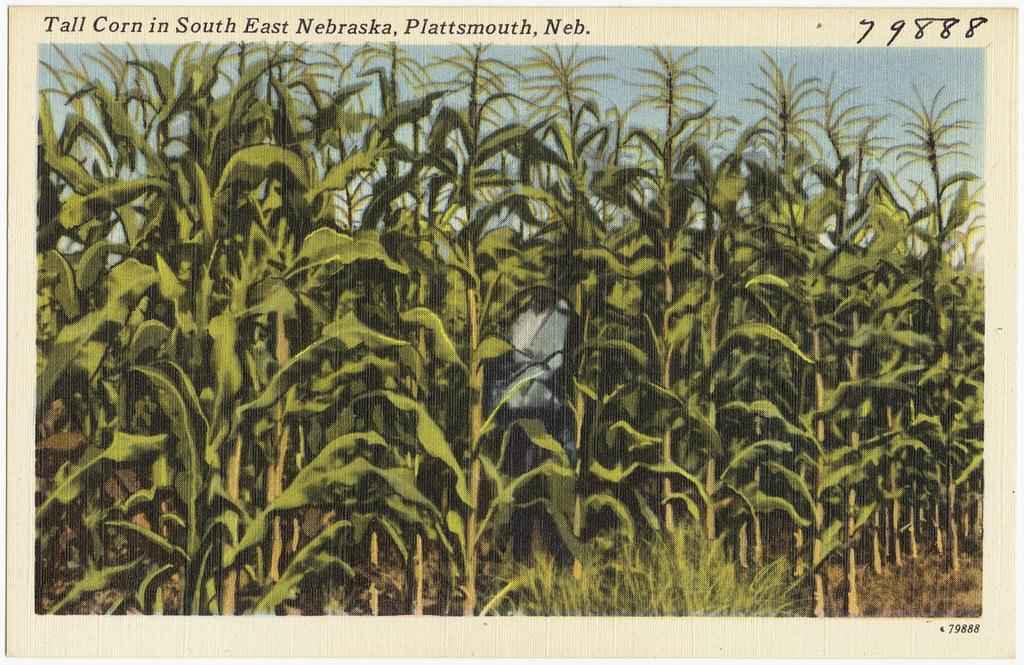What type of plants can be seen in the image? There are green color plants in the image. What part of the natural environment is visible in the image? The sky is visible in the image. What type of jeans can be seen in the image? There are no jeans present in the image. How does the wave affect the plants in the image? There is no wave present in the image, so it cannot affect the plants. 